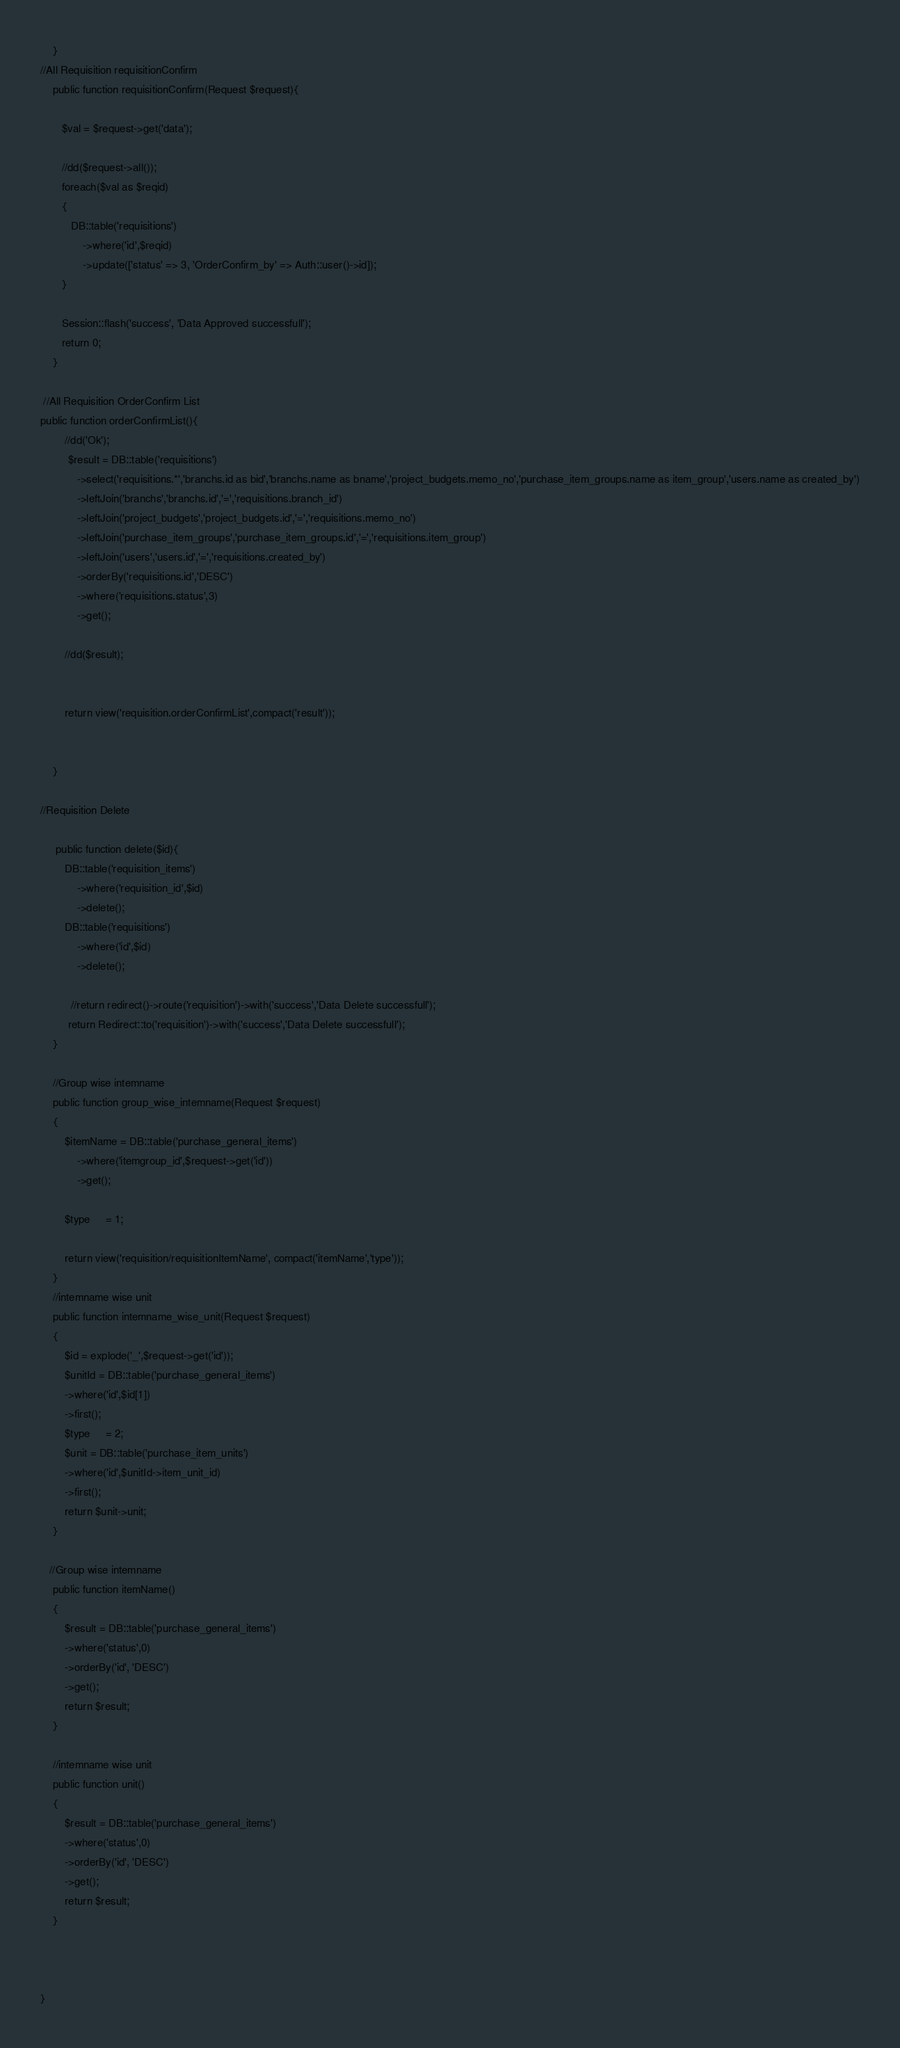Convert code to text. <code><loc_0><loc_0><loc_500><loc_500><_PHP_>    }
//All Requisition requisitionConfirm 
    public function requisitionConfirm(Request $request){

       $val = $request->get('data');

       //dd($request->all());
       foreach($val as $reqid)
       {
          DB::table('requisitions')
              ->where('id',$reqid)
              ->update(['status' => 3, 'OrderConfirm_by' => Auth::user()->id]);
       }

       Session::flash('success', 'Data Approved successfull');
       return 0;
    }

 //All Requisition OrderConfirm List  
public function orderConfirmList(){
        //dd('Ok');
         $result = DB::table('requisitions')
            ->select('requisitions.*','branchs.id as bid','branchs.name as bname','project_budgets.memo_no','purchase_item_groups.name as item_group','users.name as created_by')
            ->leftJoin('branchs','branchs.id','=','requisitions.branch_id')
            ->leftJoin('project_budgets','project_budgets.id','=','requisitions.memo_no')
            ->leftJoin('purchase_item_groups','purchase_item_groups.id','=','requisitions.item_group')
            ->leftJoin('users','users.id','=','requisitions.created_by')
            ->orderBy('requisitions.id','DESC')
            ->where('requisitions.status',3)
            ->get();

        //dd($result);
         
       
        return view('requisition.orderConfirmList',compact('result'));


    }

//Requisition Delete

     public function delete($id){
        DB::table('requisition_items')
            ->where('requisition_id',$id)
            ->delete();
        DB::table('requisitions')
            ->where('id',$id)
            ->delete();
        
          //return redirect()->route('requisition')->with('success','Data Delete successfull');
         return Redirect::to('requisition')->with('success','Data Delete successfull');
    }

    //Group wise intemname
    public function group_wise_intemname(Request $request)
    {
        $itemName = DB::table('purchase_general_items')
            ->where('itemgroup_id',$request->get('id'))
            ->get();

        $type     = 1;        

        return view('requisition/requisitionItemName', compact('itemName','type'));
    }
    //intemname wise unit
    public function intemname_wise_unit(Request $request)
    {
        $id = explode('_',$request->get('id'));
        $unitId = DB::table('purchase_general_items')
        ->where('id',$id[1])
        ->first();
        $type     = 2; 
        $unit = DB::table('purchase_item_units')
        ->where('id',$unitId->item_unit_id)
        ->first();
        return $unit->unit;
    }
    
   //Group wise intemname
    public function itemName()
    {
        $result = DB::table('purchase_general_items')
        ->where('status',0)
        ->orderBy('id', 'DESC')
        ->get();
        return $result;
    }

    //intemname wise unit
    public function unit()
    {
        $result = DB::table('purchase_general_items')
        ->where('status',0)
        ->orderBy('id', 'DESC')
        ->get();
        return $result;
    }

    

}

</code> 